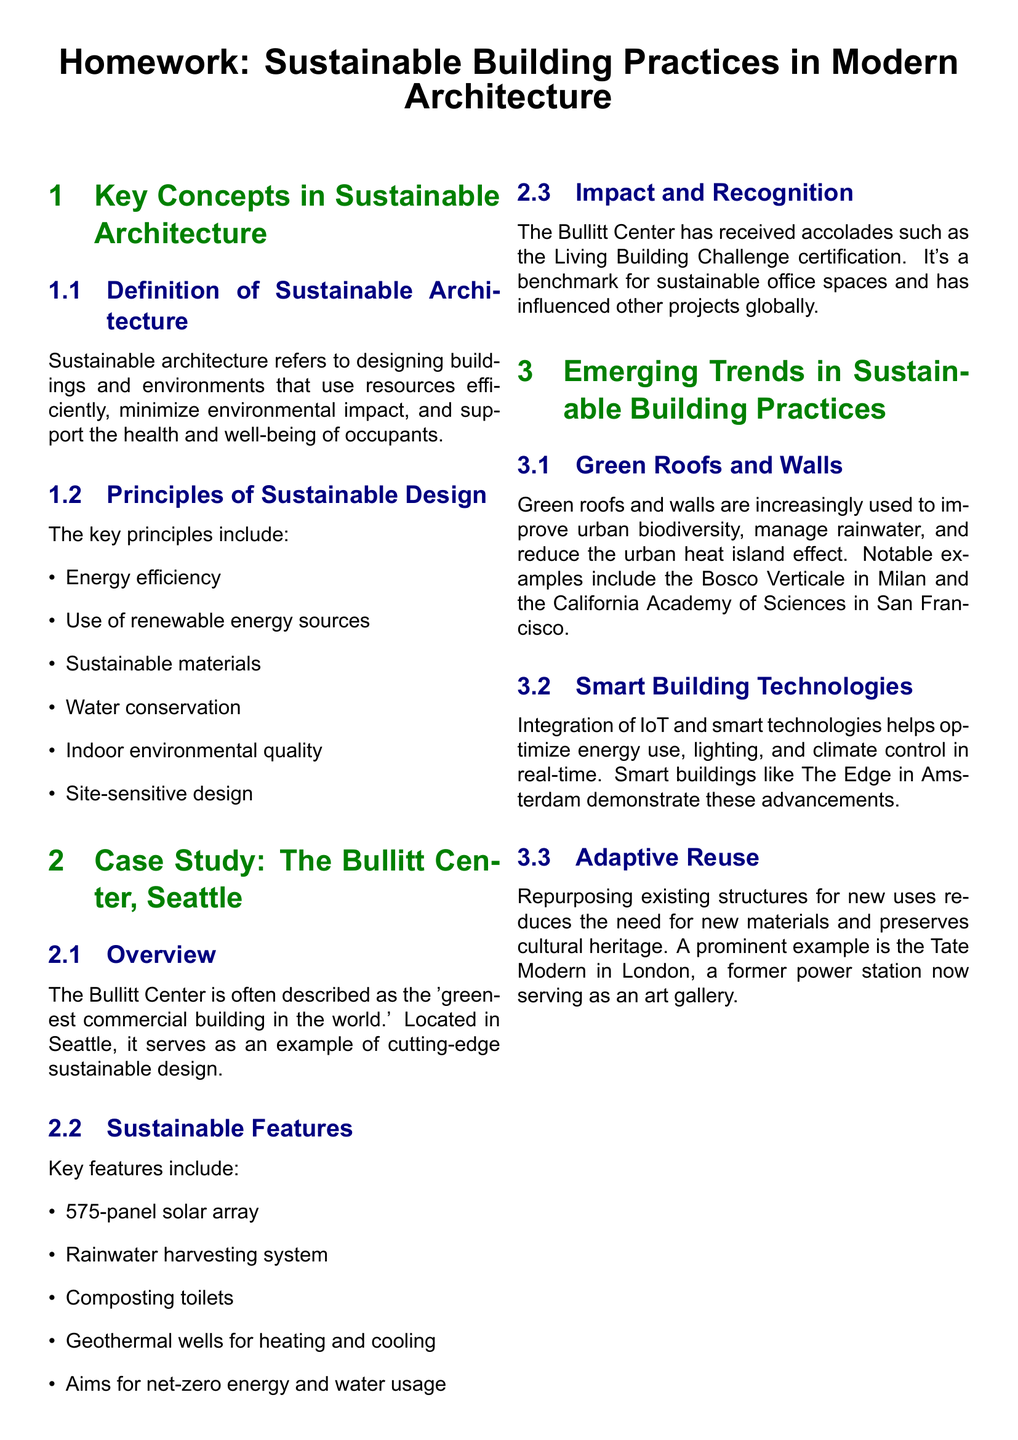what is sustainable architecture? The definition of sustainable architecture is provided in the document, emphasizing resource efficiency and minimal environmental impact.
Answer: designing buildings and environments that use resources efficiently, minimize environmental impact, and support the health and well-being of occupants list three key principles of sustainable design. The document outlines several principles of sustainable design; three of them can be extracted directly.
Answer: Energy efficiency, use of renewable energy sources, sustainable materials what is a notable feature of the Bullitt Center? The Bullitt Center features several sustainable initiatives; one example specifically mentioned is a solar energy solution.
Answer: 575-panel solar array how does the Bullitt Center manage water? The document discusses a particular system implemented at the Bullitt Center for rainwater management.
Answer: Rainwater harvesting system name an emerging trend in sustainable building. The document lists various emerging trends in sustainable building practices; one of them can be directly referenced.
Answer: Green roofs and walls how does smart building technology contribute to sustainability? The document describes the role of smart building technologies in optimizing resources, which contributes to sustainability.
Answer: It helps optimize energy use, lighting, and climate control in real-time which building serves as an example of adaptive reuse? The document mentions a cultural institution that underwent repurposing for a new use.
Answer: Tate Modern in London how many sustainable features are listed for the Bullitt Center? The document provides a specific number of key features associated with the Bullitt Center.
Answer: Five features 